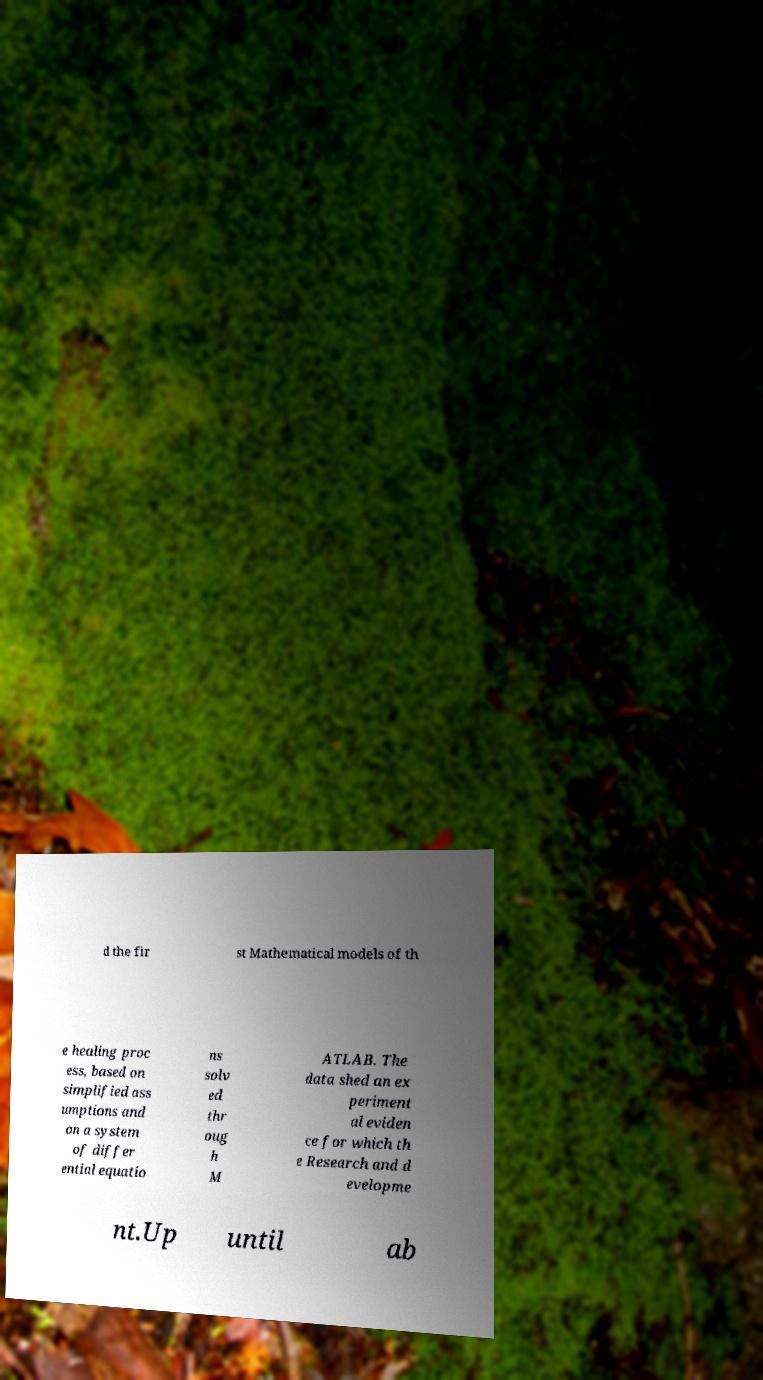Can you read and provide the text displayed in the image?This photo seems to have some interesting text. Can you extract and type it out for me? d the fir st Mathematical models of th e healing proc ess, based on simplified ass umptions and on a system of differ ential equatio ns solv ed thr oug h M ATLAB. The data shed an ex periment al eviden ce for which th e Research and d evelopme nt.Up until ab 